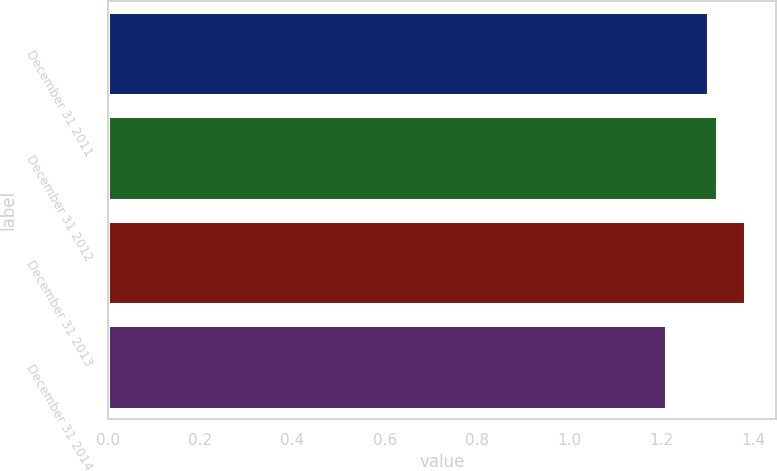Convert chart to OTSL. <chart><loc_0><loc_0><loc_500><loc_500><bar_chart><fcel>December 31 2011<fcel>December 31 2012<fcel>December 31 2013<fcel>December 31 2014<nl><fcel>1.3<fcel>1.32<fcel>1.38<fcel>1.21<nl></chart> 